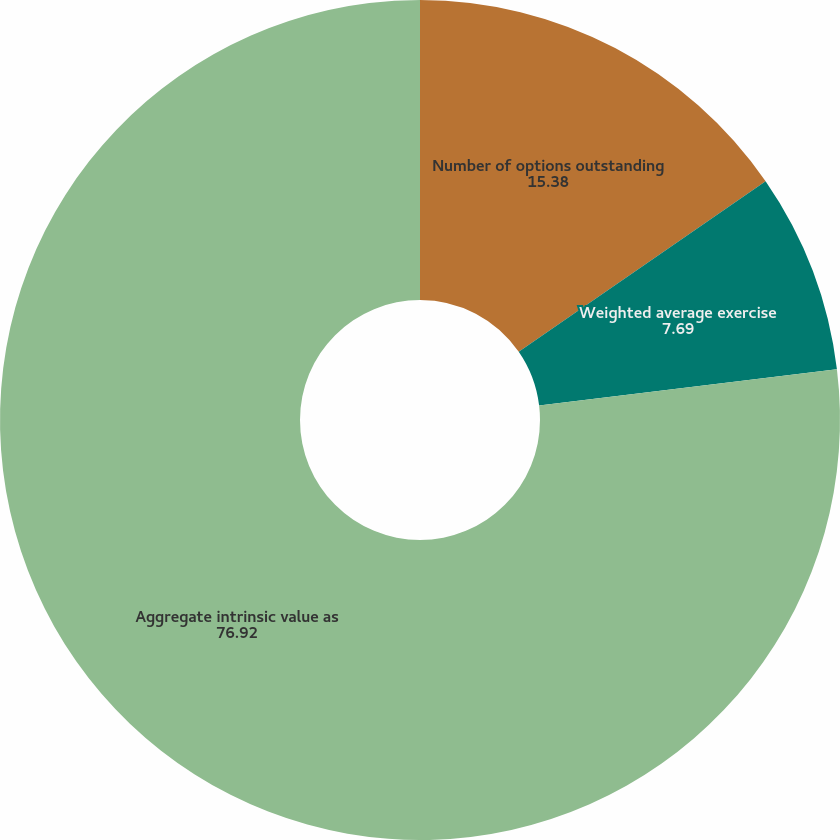Convert chart to OTSL. <chart><loc_0><loc_0><loc_500><loc_500><pie_chart><fcel>Number of options outstanding<fcel>Weighted average exercise<fcel>Aggregate intrinsic value as<fcel>Weighted average remaining<nl><fcel>15.38%<fcel>7.69%<fcel>76.92%<fcel>0.0%<nl></chart> 